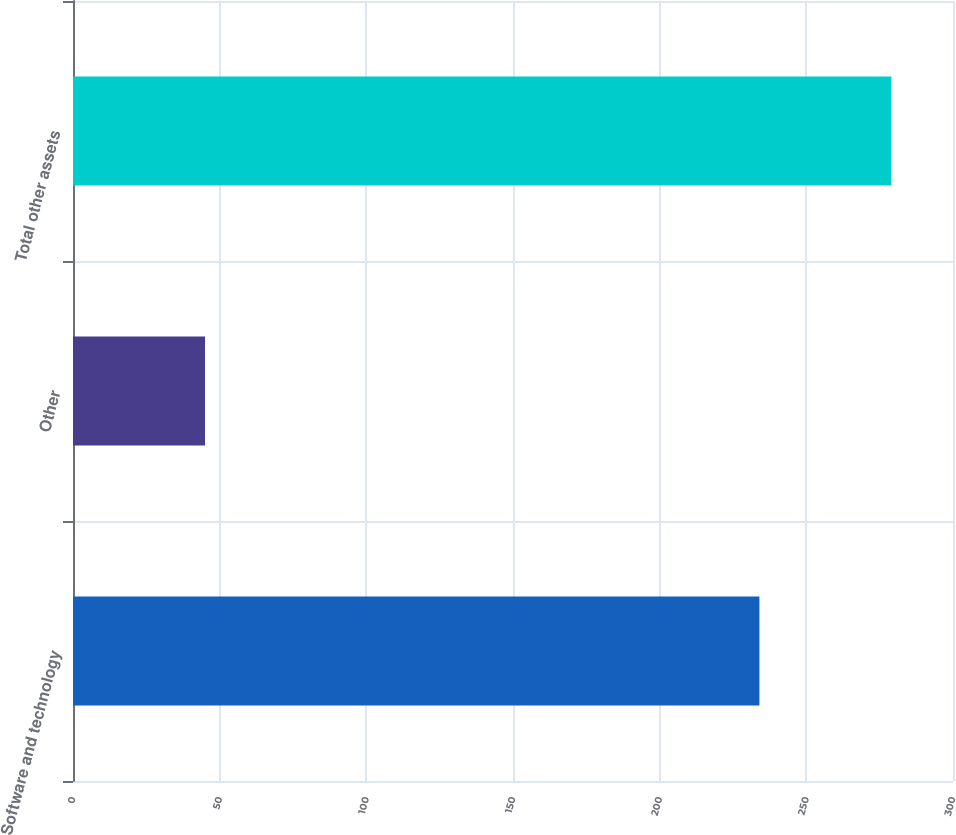<chart> <loc_0><loc_0><loc_500><loc_500><bar_chart><fcel>Software and technology<fcel>Other<fcel>Total other assets<nl><fcel>234<fcel>45<fcel>279<nl></chart> 